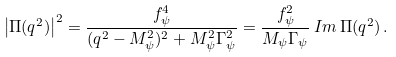Convert formula to latex. <formula><loc_0><loc_0><loc_500><loc_500>\left | \Pi ( q ^ { 2 } ) \right | ^ { 2 } = \frac { f _ { \psi } ^ { 4 } } { ( q ^ { 2 } - M _ { \psi } ^ { 2 } ) ^ { 2 } + M _ { \psi } ^ { 2 } \Gamma _ { \psi } ^ { 2 } } = \frac { f _ { \psi } ^ { 2 } } { M _ { \psi } \Gamma _ { \psi } } \, I m \, \Pi ( q ^ { 2 } ) \, .</formula> 